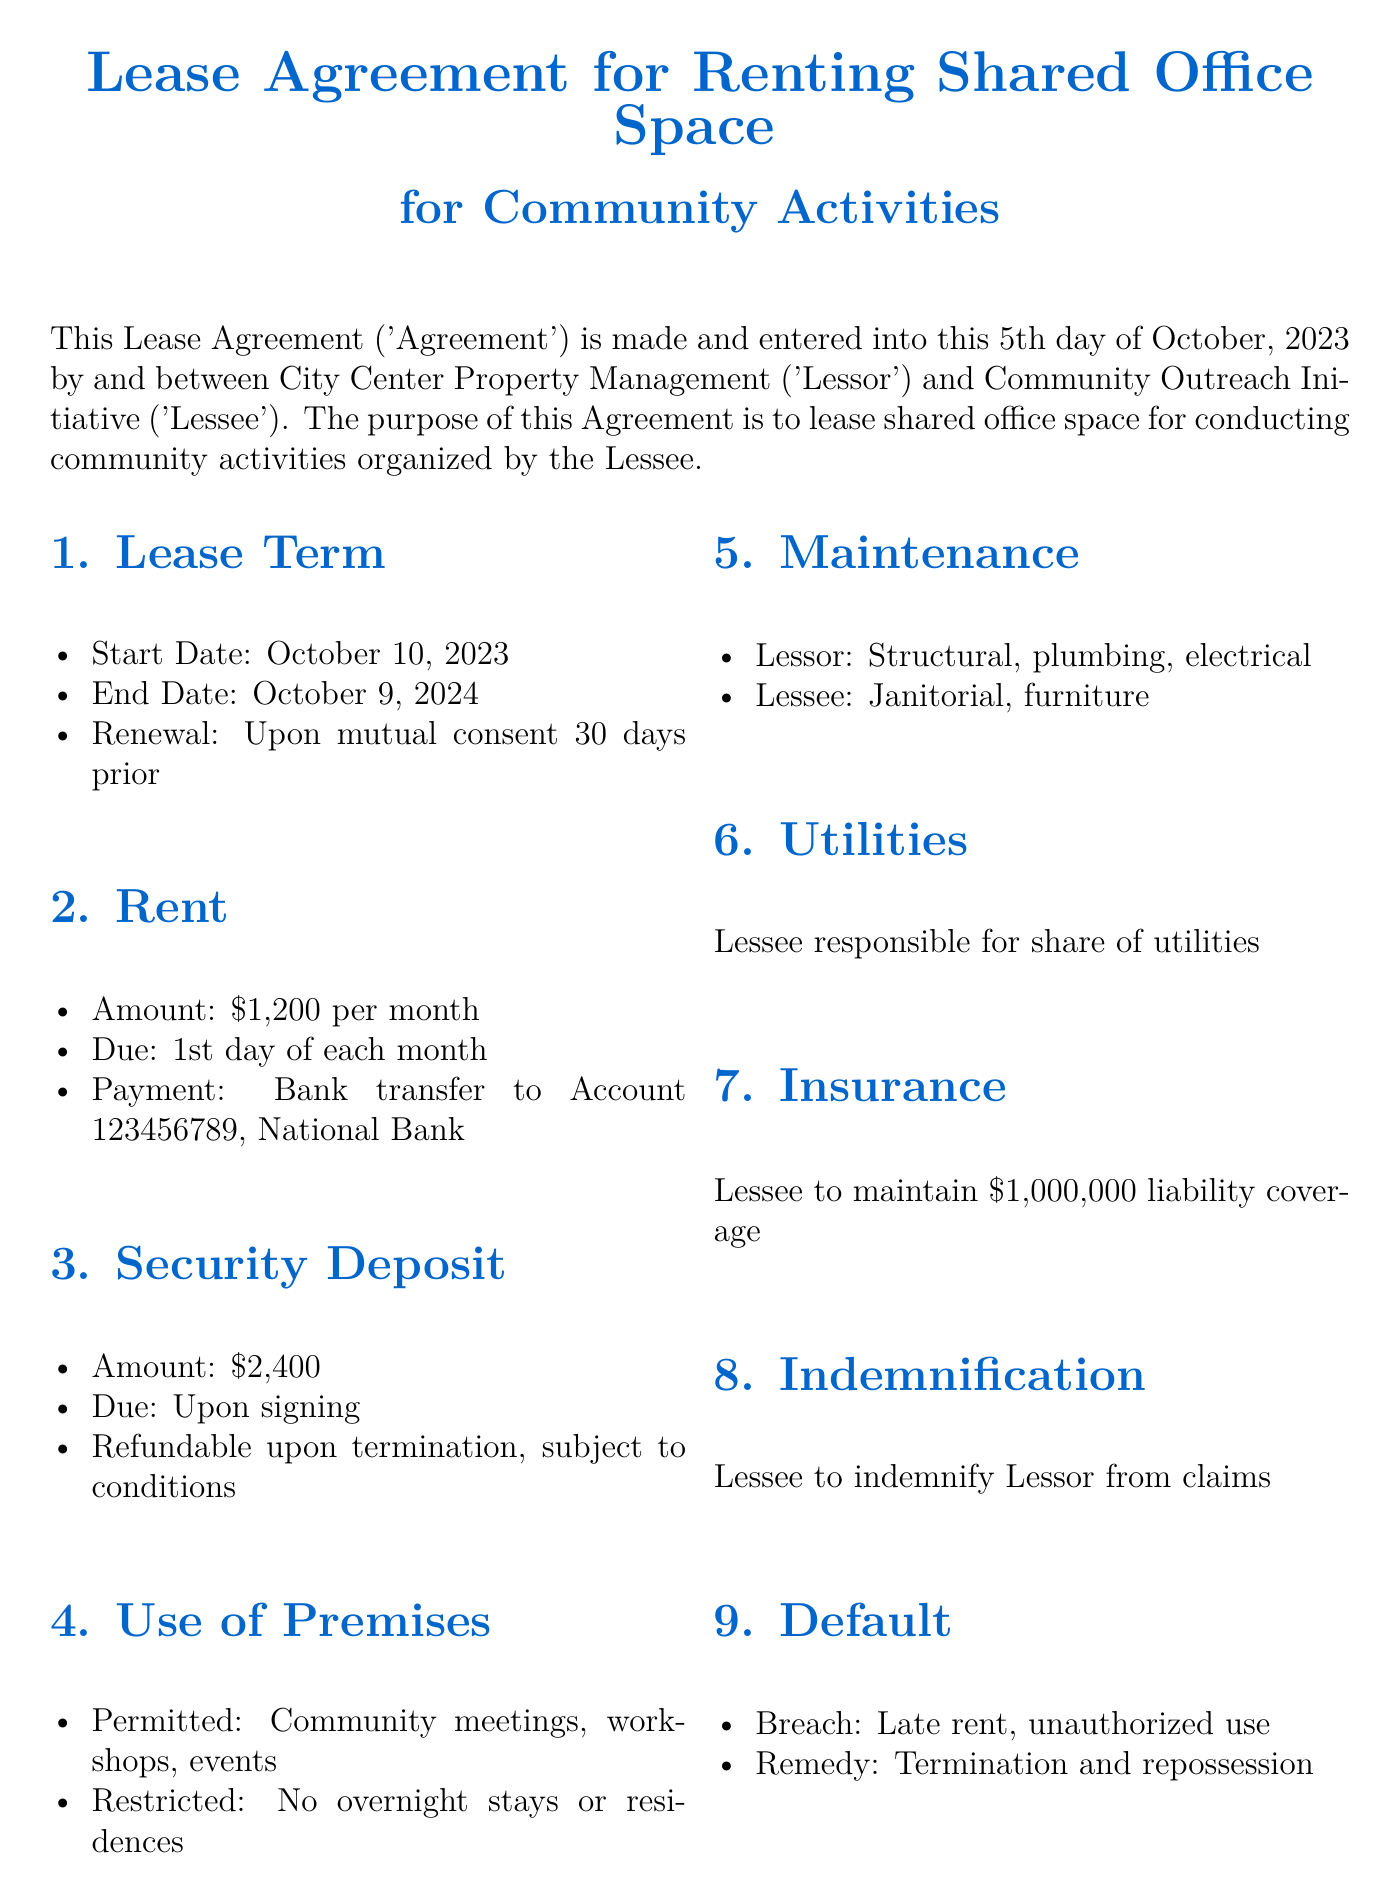What is the start date of the lease? The start date is explicitly stated as October 10, 2023.
Answer: October 10, 2023 What is the monthly rent amount? The monthly rent amount is clearly mentioned as $1,200.
Answer: $1,200 Who is the executive director of the lessee? The document lists Ibrahim Aminu Kurami as the Executive Director.
Answer: Ibrahim Aminu Kurami How long is the lease term? The lease term spans from the start date to the end date, which is one year.
Answer: One year What is the security deposit amount? The security deposit is specified as $2,400.
Answer: $2,400 What is required from the lessee regarding insurance? The lessee is required to maintain $1,000,000 liability coverage.
Answer: $1,000,000 What type of uses are permitted in the premises? The permitted uses include community meetings, workshops, and events.
Answer: Community meetings, workshops, events How many days notice is required for termination? The document states that a 60-day written notice is necessary for termination.
Answer: 60 days What must happen for lease renewal? Renewal is contingent upon mutual consent 30 days prior to the end of the lease.
Answer: Mutual consent 30 days prior 